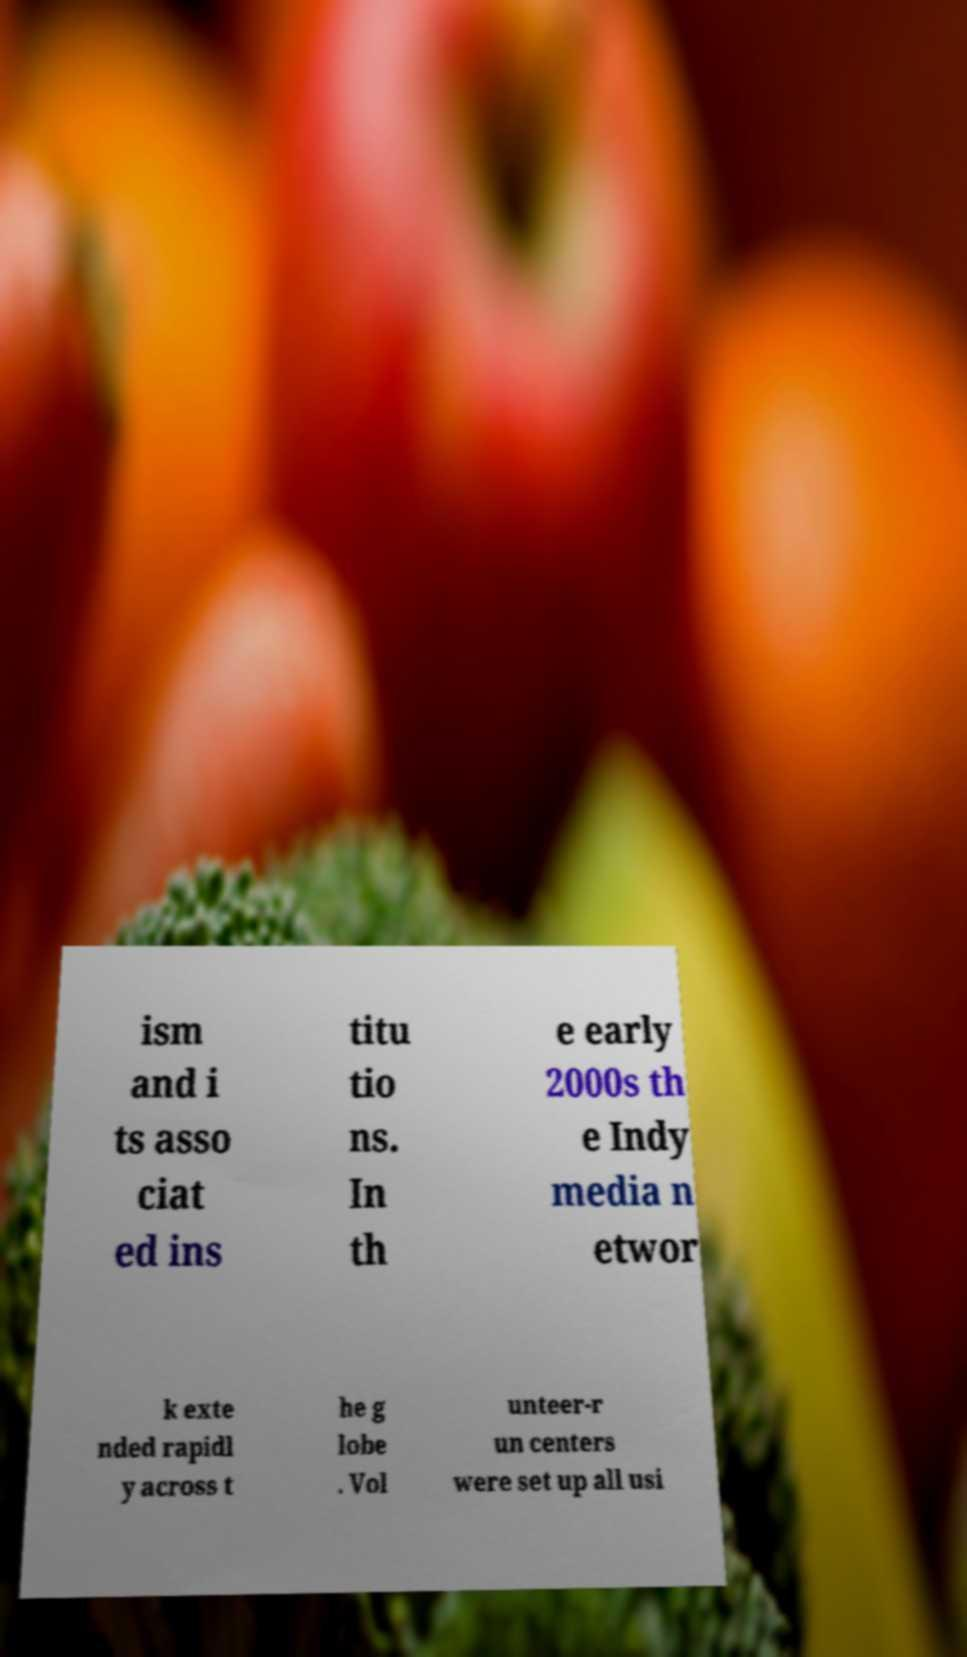Please read and relay the text visible in this image. What does it say? ism and i ts asso ciat ed ins titu tio ns. In th e early 2000s th e Indy media n etwor k exte nded rapidl y across t he g lobe . Vol unteer-r un centers were set up all usi 